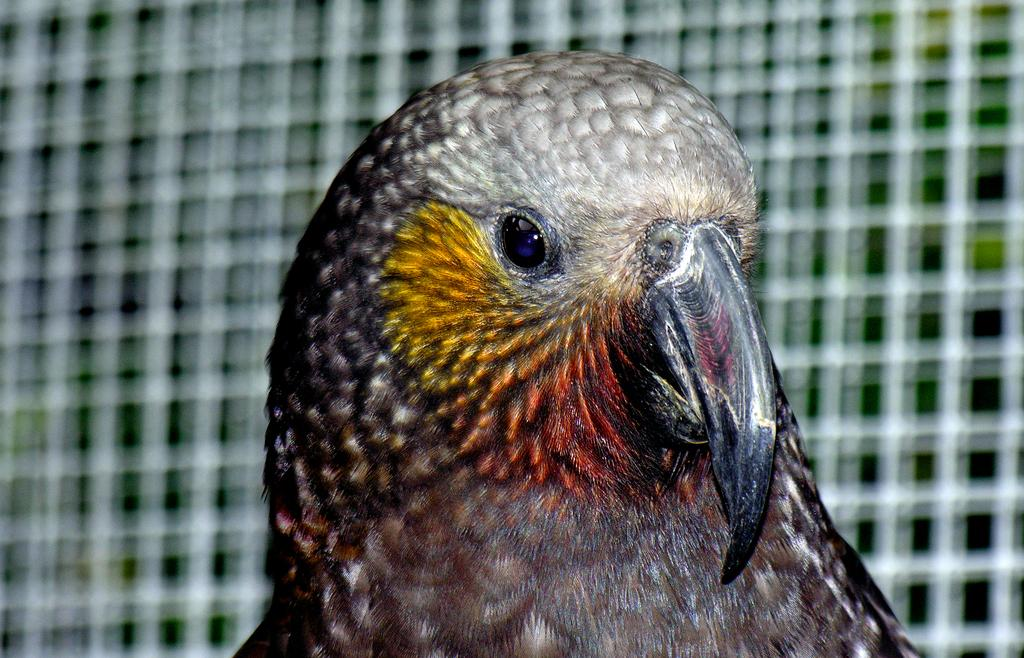What type of animal can be seen in the image? There is a bird in the image. Can you describe the background of the image? The background of the image is blurred. What type of pan is visible on the roof in the image? There is no pan or roof present in the image; it only features a bird and a blurred background. 